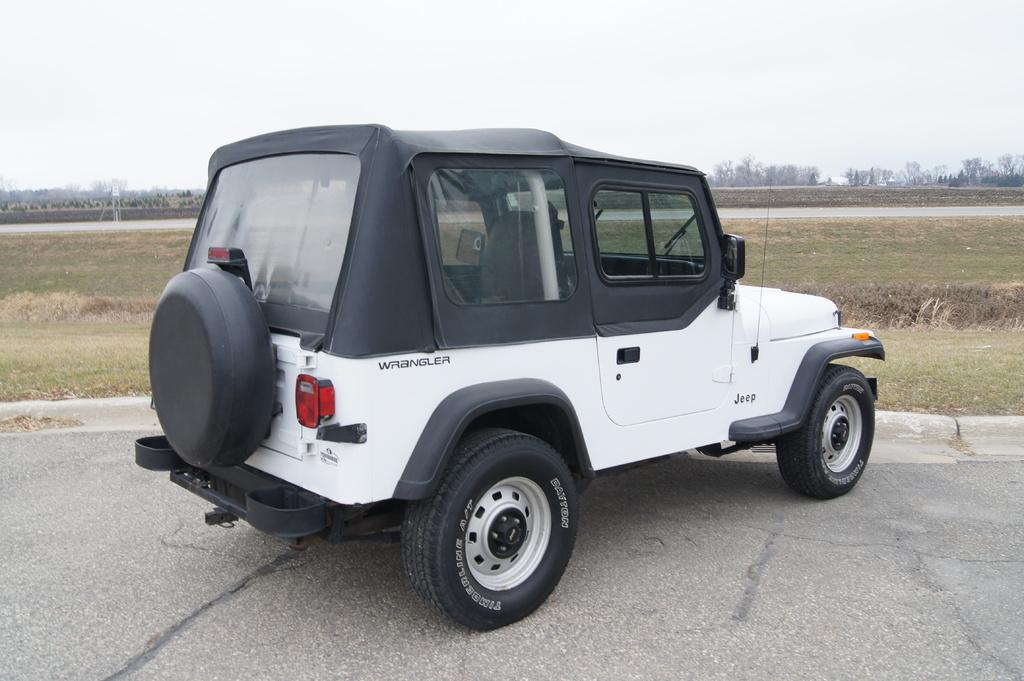What is the main subject of the image? There is a vehicle on the road in the image. Where is the vehicle located in the image? The vehicle is in the middle of the image. What can be seen in the background of the image? There is grass and trees visible in the background of the image. What type of iron is being used by the lawyer in the argument in the image? There is no iron, lawyer, or argument present in the image. The image features a vehicle on the road with grass and trees in the background. 